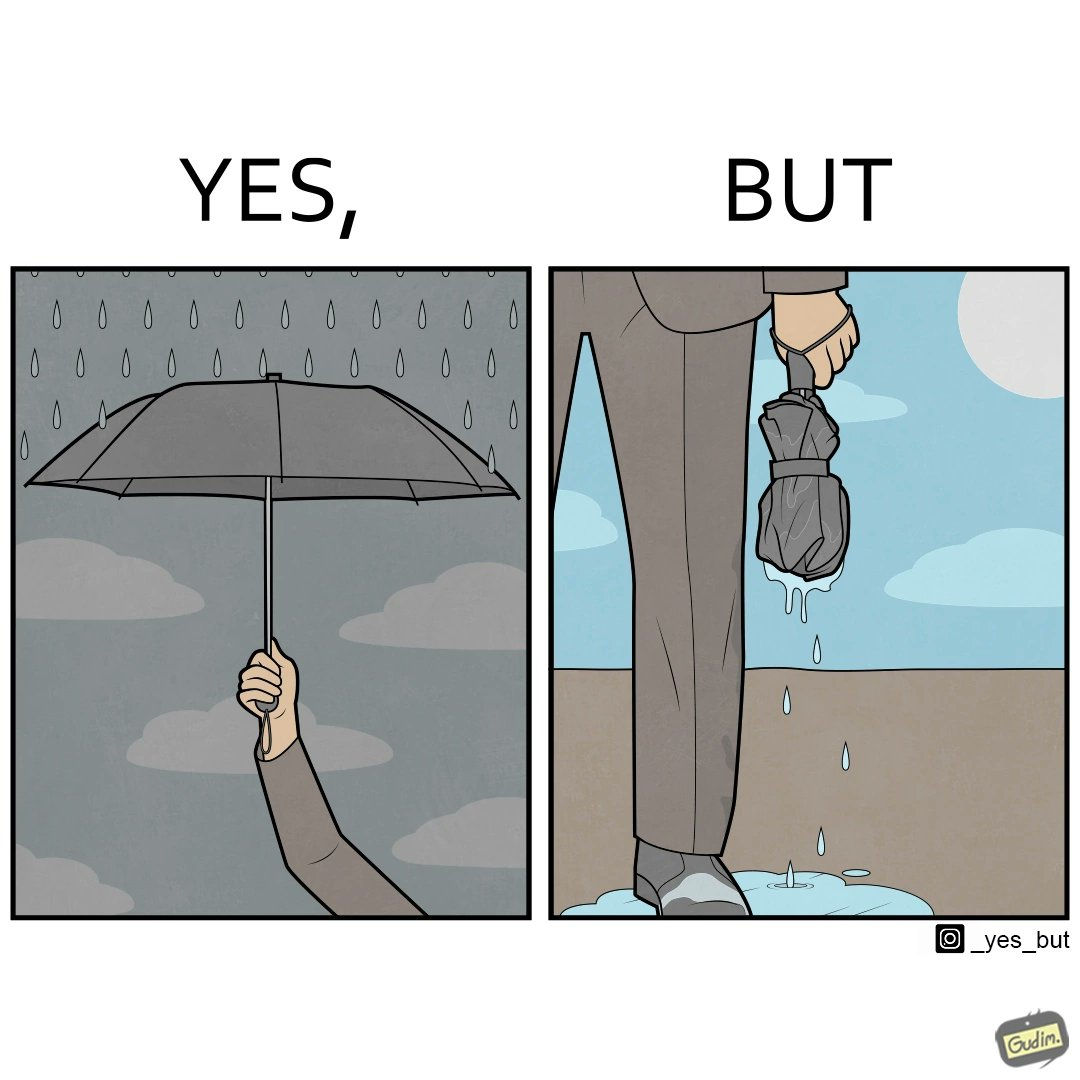Does this image contain satire or humor? Yes, this image is satirical. 